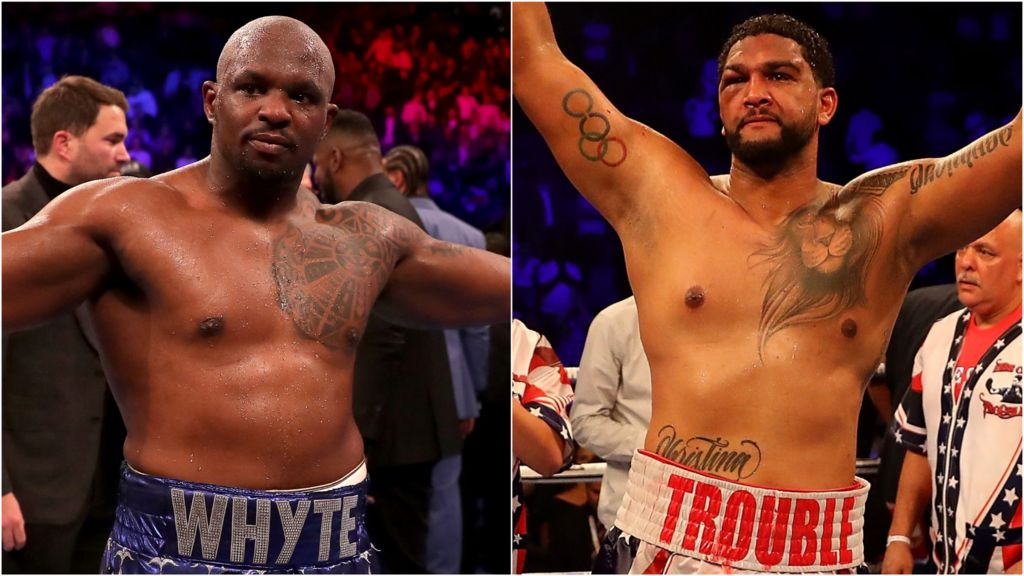What might the detailed lion tattoo on the boxer indicate about his personality or life journey? The detailed lion tattoo prominently displayed on the boxer's torso may symbolize several key aspects of his personality or life journey. Lions are often associated with qualities such as courage, strength, and leadership. This could suggest that the boxer sees himself as embodying these traits, or it may act as a daily reminder to harness these virtues in both his professional and personal life. The lion could also represent overcoming significant challenges, a proud heritage, or a spirit of dominance in the ring. Such a tattoo is likely deeply personal and could be an homage to pivotal experiences or influential figures in his life who have inspired him to persevere and succeed. 